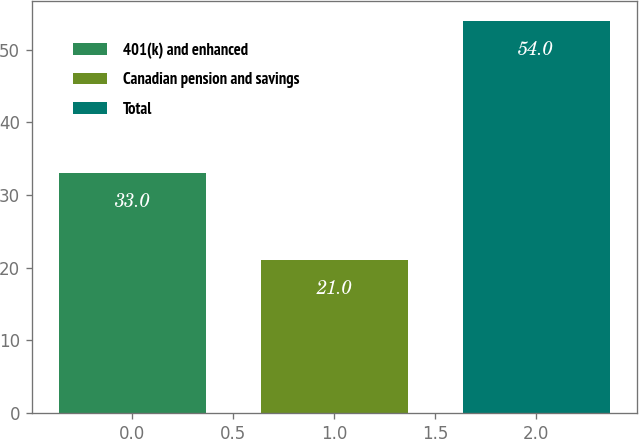Convert chart to OTSL. <chart><loc_0><loc_0><loc_500><loc_500><bar_chart><fcel>401(k) and enhanced<fcel>Canadian pension and savings<fcel>Total<nl><fcel>33<fcel>21<fcel>54<nl></chart> 